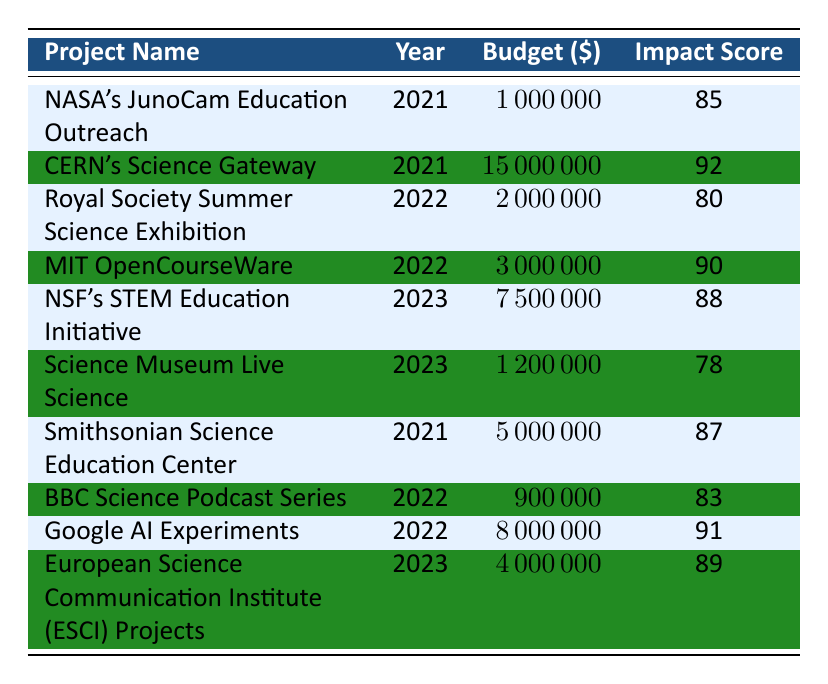What is the budget for CERN's Science Gateway project? The budget for CERN's Science Gateway project is listed in the table under the "Budget" column for the year 2021. It shows a budget of 15000000.
Answer: 15000000 What is the Impact Score of the Smithsonian Science Education Center project? The Impact Score for the Smithsonian Science Education Center is provided in the table for the year 2021, which indicates an Impact Score of 87.
Answer: 87 Which project had the highest budget in 2022? To determine which project had the highest budget in 2022, we look at the budget values of the projects from that year. The Royal Society Summer Science Exhibition had a budget of 2000000, and MIT OpenCourseWare had a budget of 3000000. Therefore, MIT OpenCourseWare had the highest budget.
Answer: MIT OpenCourseWare What is the average Impact Score of all projects listed for the year 2023? The Impact Scores for projects in 2023 are 88 (NSF's STEM Education Initiative), 78 (Science Museum Live Science), and 89 (European Science Communication Institute Projects). We sum these scores: 88 + 78 + 89 = 255. There are 3 projects, so the average is 255 / 3 = 85.
Answer: 85 Is it true that the budget for the NASA's JunoCam Education Outreach project is greater than that of the Science Museum Live Science project? The budget for NASA's JunoCam Education Outreach is 1000000, while the budget for Science Museum Live Science is 1200000. Since 1000000 is less than 1200000, the statement is false.
Answer: No Which project has the lowest Impact Score in 2022? Looking at the table, the Impact Scores for 2022 are 80 (Royal Society Summer Science Exhibition), 90 (MIT OpenCourseWare), 83 (BBC Science Podcast Series), and 91 (Google AI Experiments). The lowest among these is 80, corresponding to the Royal Society Summer Science Exhibition.
Answer: Royal Society Summer Science Exhibition What is the total budget of all the projects organized by NSF? The only project organized by the National Science Foundation (NSF) is the NSF's STEM Education Initiative, which has a budget of 7500000. This means the total budget for all NSF projects is simply this value, as there are no other entries.
Answer: 7500000 Which organization had the highest average Impact Score across its projects? To find the highest average Impact Score, we calculate the average for each organization based on their listed projects. NASA has one project with an Impact Score of 85, total = 85. CERN has one project with a score of 92, total = 92. The Royal Society has one project with a score of 80, total = 80. MIT has one with a score of 90, total = 90. NSF has one project at 88. The Science Museum Group has 78, and the Smithsonian has 87. BBC has 83 and Google has 91 while ESCI has 89. The highest average is for CERN at 92, as it is the only project they have.
Answer: CERN 